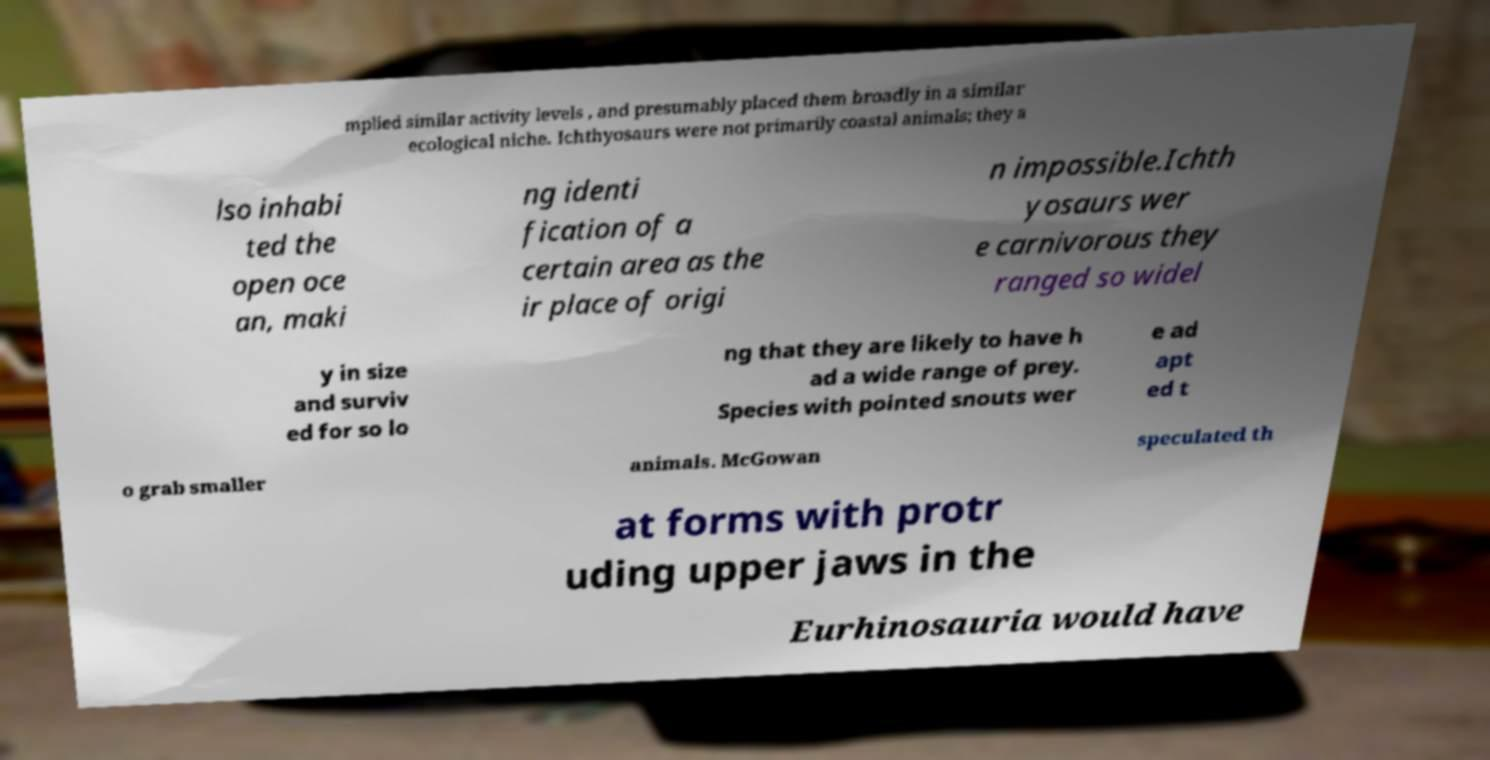Please read and relay the text visible in this image. What does it say? mplied similar activity levels , and presumably placed them broadly in a similar ecological niche. Ichthyosaurs were not primarily coastal animals; they a lso inhabi ted the open oce an, maki ng identi fication of a certain area as the ir place of origi n impossible.Ichth yosaurs wer e carnivorous they ranged so widel y in size and surviv ed for so lo ng that they are likely to have h ad a wide range of prey. Species with pointed snouts wer e ad apt ed t o grab smaller animals. McGowan speculated th at forms with protr uding upper jaws in the Eurhinosauria would have 